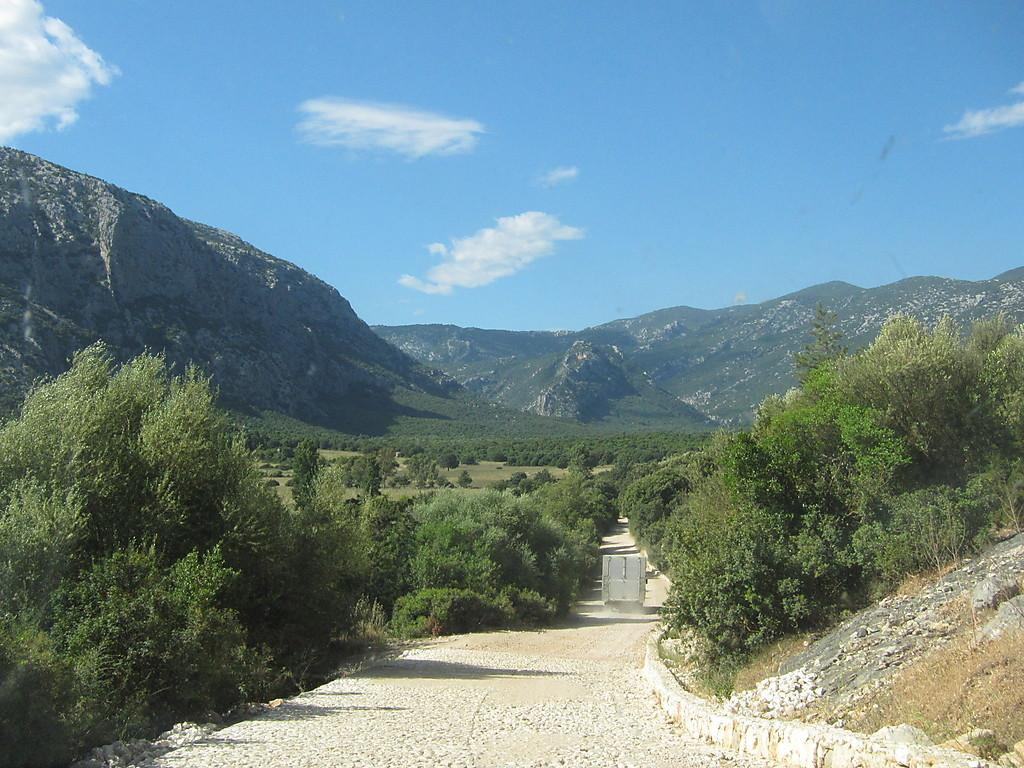What type of natural elements can be seen in the image? There are trees in the image. What man-made structure is present in the image? There is a road in the image. What is moving along the road in the image? A vehicle is visible on the road. What can be seen in the distance in the image? There is a mountain in the background of the image. What is visible above the mountain in the image? The sky is visible in the background of the image. What type of vegetable is being smashed on the road in the image? There is no vegetable being smashed on the road in the image. What show is being performed on the mountain in the image? There is no show being performed on the mountain in the image. 